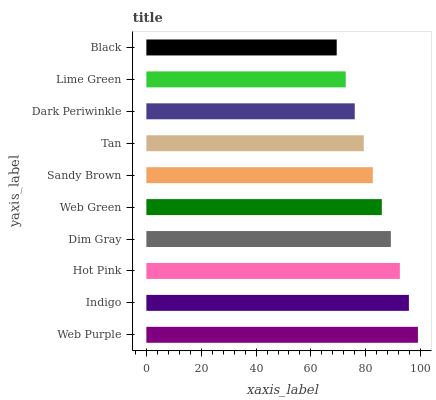Is Black the minimum?
Answer yes or no. Yes. Is Web Purple the maximum?
Answer yes or no. Yes. Is Indigo the minimum?
Answer yes or no. No. Is Indigo the maximum?
Answer yes or no. No. Is Web Purple greater than Indigo?
Answer yes or no. Yes. Is Indigo less than Web Purple?
Answer yes or no. Yes. Is Indigo greater than Web Purple?
Answer yes or no. No. Is Web Purple less than Indigo?
Answer yes or no. No. Is Web Green the high median?
Answer yes or no. Yes. Is Sandy Brown the low median?
Answer yes or no. Yes. Is Dark Periwinkle the high median?
Answer yes or no. No. Is Dim Gray the low median?
Answer yes or no. No. 